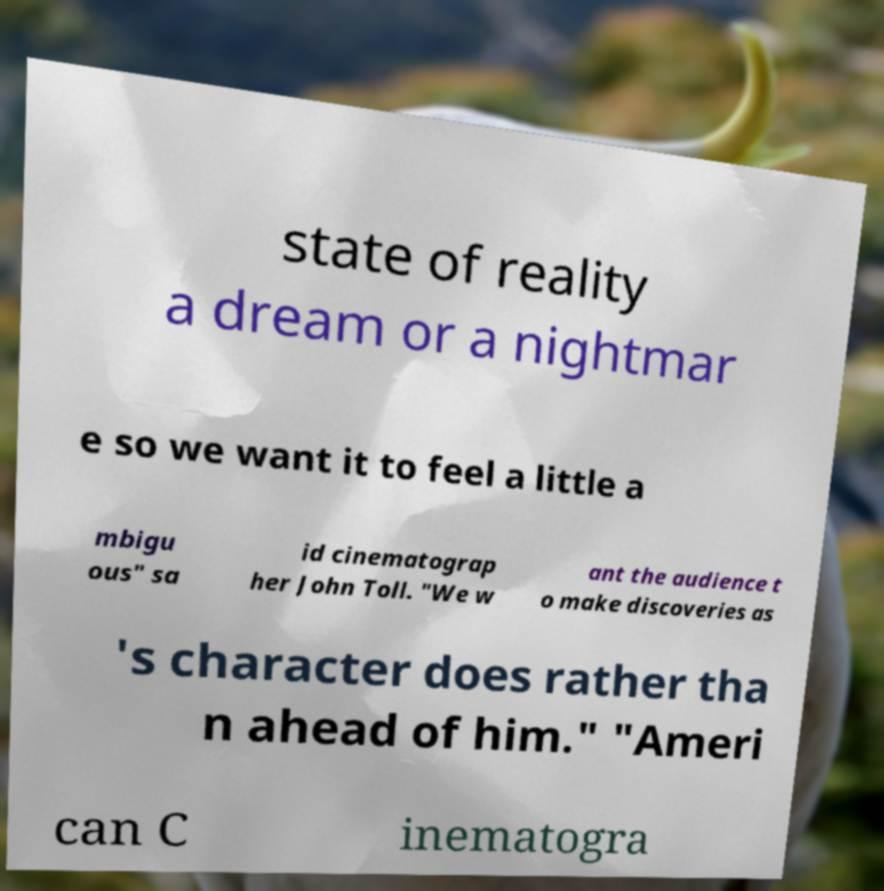Could you assist in decoding the text presented in this image and type it out clearly? state of reality a dream or a nightmar e so we want it to feel a little a mbigu ous" sa id cinematograp her John Toll. "We w ant the audience t o make discoveries as 's character does rather tha n ahead of him." "Ameri can C inematogra 